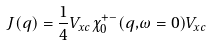Convert formula to latex. <formula><loc_0><loc_0><loc_500><loc_500>J ( { q } ) = \frac { 1 } { 4 } V _ { x c } \chi _ { 0 } ^ { + - } ( { q , } \omega = 0 ) V _ { x c }</formula> 